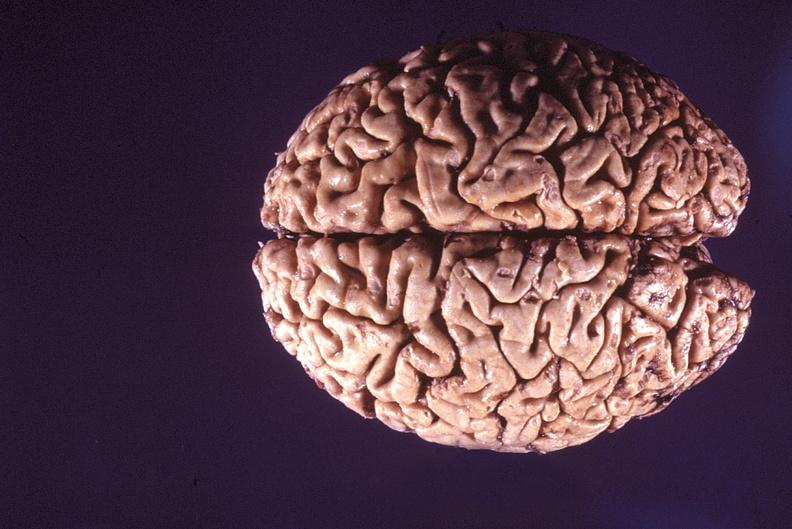what does this image show?
Answer the question using a single word or phrase. Normal brain 